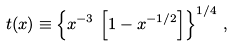Convert formula to latex. <formula><loc_0><loc_0><loc_500><loc_500>t ( x ) \equiv \left \{ x ^ { - 3 } \, \left [ 1 - x ^ { - 1 / 2 } \right ] \right \} ^ { 1 / 4 } \, ,</formula> 